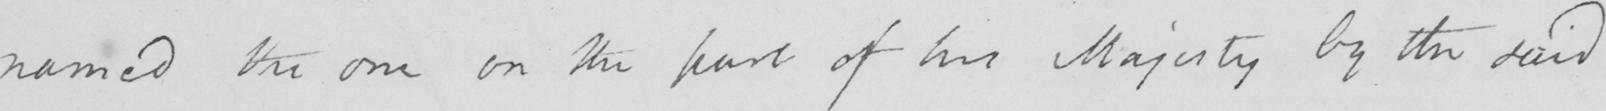Please provide the text content of this handwritten line. named the one on the part of his Majesty by the said 